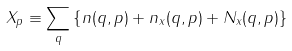<formula> <loc_0><loc_0><loc_500><loc_500>X _ { p } \equiv \sum _ { q } \left \{ n ( q , p ) + n _ { x } ( q , p ) + N _ { x } ( q , p ) \right \}</formula> 